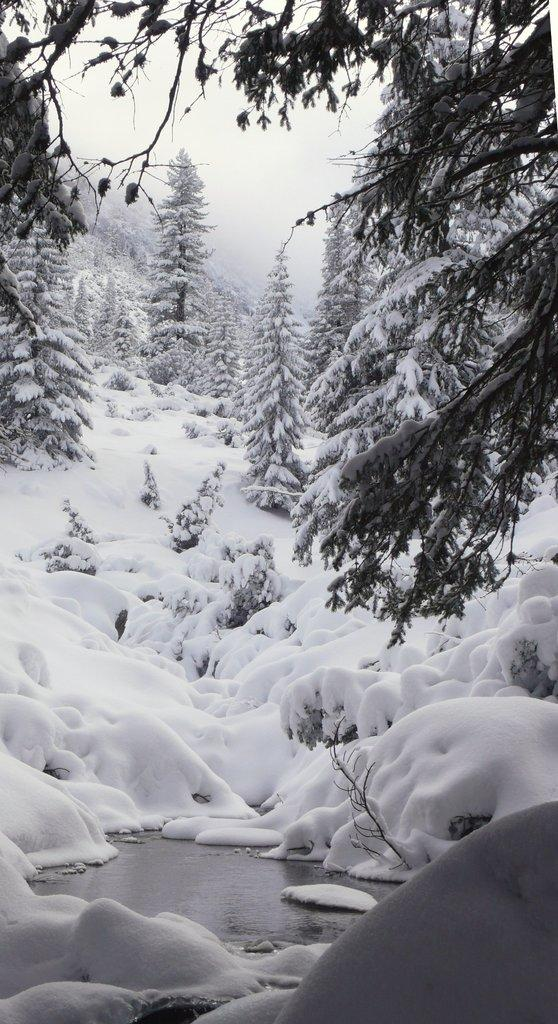What is present at the bottom of the picture? There is water and ice at the bottom of the picture. What can be seen in the background of the image? There are trees in the background of the image. How are the trees in the image affected by the weather? The trees are covered with ice, indicating that it is likely cold or freezing. What is visible at the top of the image? The sky is visible at the top of the image. How many quarters can be seen on the trees in the image? There are no quarters present in the image; the trees are covered with ice. Can you see any ghosts in the image? There are no ghosts present in the image; it features trees covered with ice and a sky visible at the top. 